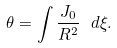<formula> <loc_0><loc_0><loc_500><loc_500>\theta = \int \frac { J _ { 0 } } { R ^ { 2 } } \ d \xi .</formula> 